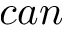Convert formula to latex. <formula><loc_0><loc_0><loc_500><loc_500>c a n</formula> 